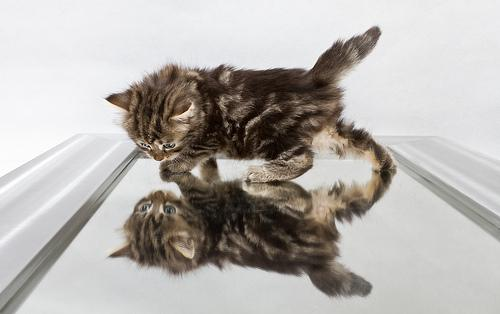Question: why are there two cats?
Choices:
A. To play.
B. To watch.
C. One is reflection.
D. There isn't.
Answer with the letter. Answer: C Question: when was this taken?
Choices:
A. Day time.
B. Early.
C. Mid day.
D. During the day.
Answer with the letter. Answer: D Question: what kind of cat is this?
Choices:
A. Kitten.
B. Baby cat.
C. Ugly one.
D. Small one.
Answer with the letter. Answer: A Question: who is in the photo?
Choices:
A. People.
B. Animals.
C. No one.
D. Workers.
Answer with the letter. Answer: C 